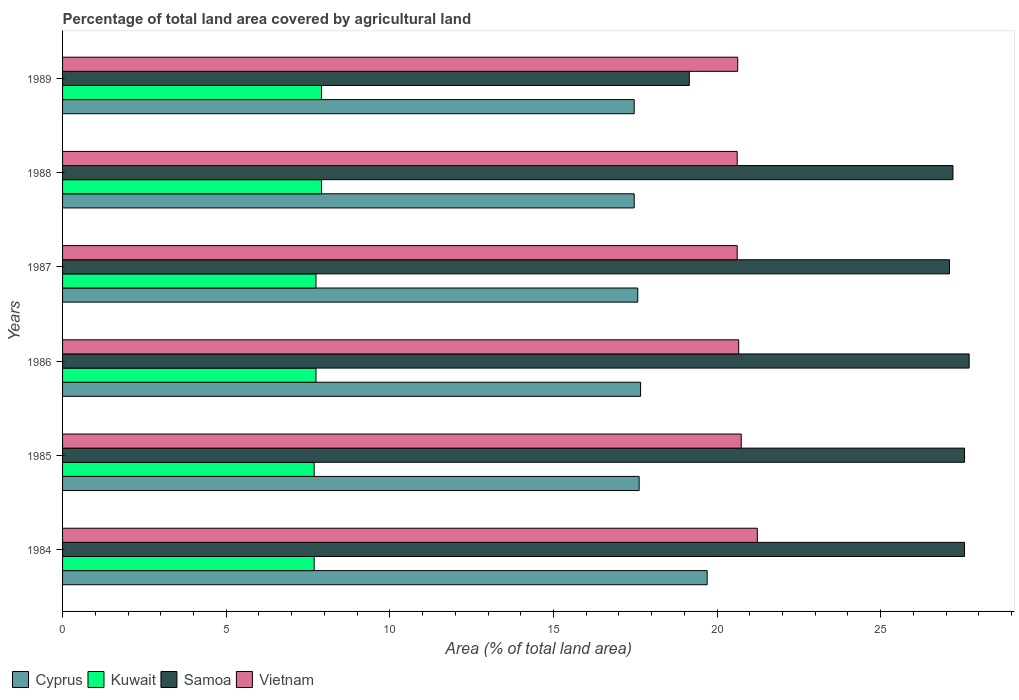How many groups of bars are there?
Offer a terse response. 6. How many bars are there on the 5th tick from the top?
Your answer should be very brief. 4. How many bars are there on the 4th tick from the bottom?
Your answer should be compact. 4. What is the percentage of agricultural land in Samoa in 1984?
Your answer should be very brief. 27.56. Across all years, what is the maximum percentage of agricultural land in Vietnam?
Your answer should be very brief. 21.23. Across all years, what is the minimum percentage of agricultural land in Samoa?
Keep it short and to the point. 19.15. In which year was the percentage of agricultural land in Vietnam minimum?
Ensure brevity in your answer.  1987. What is the total percentage of agricultural land in Cyprus in the graph?
Offer a very short reply. 107.49. What is the difference between the percentage of agricultural land in Kuwait in 1986 and that in 1987?
Offer a terse response. 0. What is the difference between the percentage of agricultural land in Cyprus in 1985 and the percentage of agricultural land in Kuwait in 1989?
Provide a short and direct response. 9.71. What is the average percentage of agricultural land in Cyprus per year?
Provide a succinct answer. 17.91. In the year 1984, what is the difference between the percentage of agricultural land in Kuwait and percentage of agricultural land in Vietnam?
Your response must be concise. -13.54. Is the difference between the percentage of agricultural land in Kuwait in 1985 and 1986 greater than the difference between the percentage of agricultural land in Vietnam in 1985 and 1986?
Your response must be concise. No. What is the difference between the highest and the second highest percentage of agricultural land in Kuwait?
Offer a terse response. 0. What is the difference between the highest and the lowest percentage of agricultural land in Samoa?
Keep it short and to the point. 8.55. What does the 3rd bar from the top in 1987 represents?
Your answer should be very brief. Kuwait. What does the 3rd bar from the bottom in 1989 represents?
Give a very brief answer. Samoa. Is it the case that in every year, the sum of the percentage of agricultural land in Vietnam and percentage of agricultural land in Cyprus is greater than the percentage of agricultural land in Samoa?
Make the answer very short. Yes. How many bars are there?
Give a very brief answer. 24. Are all the bars in the graph horizontal?
Make the answer very short. Yes. What is the difference between two consecutive major ticks on the X-axis?
Your response must be concise. 5. Does the graph contain any zero values?
Your answer should be compact. No. Does the graph contain grids?
Make the answer very short. No. What is the title of the graph?
Your answer should be very brief. Percentage of total land area covered by agricultural land. What is the label or title of the X-axis?
Your answer should be very brief. Area (% of total land area). What is the label or title of the Y-axis?
Keep it short and to the point. Years. What is the Area (% of total land area) of Cyprus in 1984?
Your answer should be compact. 19.7. What is the Area (% of total land area) in Kuwait in 1984?
Your response must be concise. 7.69. What is the Area (% of total land area) in Samoa in 1984?
Your answer should be very brief. 27.56. What is the Area (% of total land area) in Vietnam in 1984?
Make the answer very short. 21.23. What is the Area (% of total land area) in Cyprus in 1985?
Your answer should be very brief. 17.62. What is the Area (% of total land area) of Kuwait in 1985?
Provide a short and direct response. 7.69. What is the Area (% of total land area) of Samoa in 1985?
Keep it short and to the point. 27.56. What is the Area (% of total land area) of Vietnam in 1985?
Your answer should be compact. 20.74. What is the Area (% of total land area) in Cyprus in 1986?
Keep it short and to the point. 17.66. What is the Area (% of total land area) of Kuwait in 1986?
Your answer should be compact. 7.74. What is the Area (% of total land area) of Samoa in 1986?
Your answer should be compact. 27.7. What is the Area (% of total land area) in Vietnam in 1986?
Keep it short and to the point. 20.66. What is the Area (% of total land area) of Cyprus in 1987?
Offer a terse response. 17.58. What is the Area (% of total land area) in Kuwait in 1987?
Give a very brief answer. 7.74. What is the Area (% of total land area) of Samoa in 1987?
Give a very brief answer. 27.1. What is the Area (% of total land area) in Vietnam in 1987?
Provide a short and direct response. 20.62. What is the Area (% of total land area) of Cyprus in 1988?
Your response must be concise. 17.47. What is the Area (% of total land area) of Kuwait in 1988?
Your response must be concise. 7.91. What is the Area (% of total land area) in Samoa in 1988?
Your answer should be compact. 27.21. What is the Area (% of total land area) of Vietnam in 1988?
Offer a very short reply. 20.62. What is the Area (% of total land area) of Cyprus in 1989?
Keep it short and to the point. 17.47. What is the Area (% of total land area) of Kuwait in 1989?
Offer a terse response. 7.91. What is the Area (% of total land area) in Samoa in 1989?
Your response must be concise. 19.15. What is the Area (% of total land area) in Vietnam in 1989?
Your response must be concise. 20.63. Across all years, what is the maximum Area (% of total land area) in Cyprus?
Offer a terse response. 19.7. Across all years, what is the maximum Area (% of total land area) of Kuwait?
Give a very brief answer. 7.91. Across all years, what is the maximum Area (% of total land area) in Samoa?
Offer a terse response. 27.7. Across all years, what is the maximum Area (% of total land area) of Vietnam?
Your answer should be compact. 21.23. Across all years, what is the minimum Area (% of total land area) in Cyprus?
Provide a short and direct response. 17.47. Across all years, what is the minimum Area (% of total land area) in Kuwait?
Your response must be concise. 7.69. Across all years, what is the minimum Area (% of total land area) of Samoa?
Give a very brief answer. 19.15. Across all years, what is the minimum Area (% of total land area) in Vietnam?
Ensure brevity in your answer.  20.62. What is the total Area (% of total land area) in Cyprus in the graph?
Ensure brevity in your answer.  107.49. What is the total Area (% of total land area) of Kuwait in the graph?
Keep it short and to the point. 46.69. What is the total Area (% of total land area) of Samoa in the graph?
Give a very brief answer. 156.29. What is the total Area (% of total land area) in Vietnam in the graph?
Your answer should be compact. 124.49. What is the difference between the Area (% of total land area) of Cyprus in 1984 and that in 1985?
Give a very brief answer. 2.08. What is the difference between the Area (% of total land area) in Vietnam in 1984 and that in 1985?
Offer a very short reply. 0.49. What is the difference between the Area (% of total land area) in Cyprus in 1984 and that in 1986?
Provide a succinct answer. 2.03. What is the difference between the Area (% of total land area) in Kuwait in 1984 and that in 1986?
Ensure brevity in your answer.  -0.06. What is the difference between the Area (% of total land area) of Samoa in 1984 and that in 1986?
Give a very brief answer. -0.14. What is the difference between the Area (% of total land area) in Vietnam in 1984 and that in 1986?
Provide a succinct answer. 0.57. What is the difference between the Area (% of total land area) of Cyprus in 1984 and that in 1987?
Provide a succinct answer. 2.12. What is the difference between the Area (% of total land area) of Kuwait in 1984 and that in 1987?
Ensure brevity in your answer.  -0.06. What is the difference between the Area (% of total land area) of Samoa in 1984 and that in 1987?
Offer a very short reply. 0.46. What is the difference between the Area (% of total land area) in Vietnam in 1984 and that in 1987?
Provide a succinct answer. 0.61. What is the difference between the Area (% of total land area) in Cyprus in 1984 and that in 1988?
Make the answer very short. 2.23. What is the difference between the Area (% of total land area) in Kuwait in 1984 and that in 1988?
Keep it short and to the point. -0.22. What is the difference between the Area (% of total land area) of Samoa in 1984 and that in 1988?
Give a very brief answer. 0.35. What is the difference between the Area (% of total land area) in Vietnam in 1984 and that in 1988?
Your response must be concise. 0.61. What is the difference between the Area (% of total land area) of Cyprus in 1984 and that in 1989?
Provide a short and direct response. 2.23. What is the difference between the Area (% of total land area) in Kuwait in 1984 and that in 1989?
Make the answer very short. -0.22. What is the difference between the Area (% of total land area) in Samoa in 1984 and that in 1989?
Your answer should be very brief. 8.41. What is the difference between the Area (% of total land area) of Vietnam in 1984 and that in 1989?
Your response must be concise. 0.6. What is the difference between the Area (% of total land area) of Cyprus in 1985 and that in 1986?
Make the answer very short. -0.04. What is the difference between the Area (% of total land area) in Kuwait in 1985 and that in 1986?
Your answer should be very brief. -0.06. What is the difference between the Area (% of total land area) of Samoa in 1985 and that in 1986?
Your answer should be very brief. -0.14. What is the difference between the Area (% of total land area) in Vietnam in 1985 and that in 1986?
Provide a short and direct response. 0.08. What is the difference between the Area (% of total land area) of Cyprus in 1985 and that in 1987?
Your answer should be very brief. 0.04. What is the difference between the Area (% of total land area) in Kuwait in 1985 and that in 1987?
Ensure brevity in your answer.  -0.06. What is the difference between the Area (% of total land area) of Samoa in 1985 and that in 1987?
Make the answer very short. 0.46. What is the difference between the Area (% of total land area) in Vietnam in 1985 and that in 1987?
Offer a terse response. 0.12. What is the difference between the Area (% of total land area) of Cyprus in 1985 and that in 1988?
Offer a terse response. 0.15. What is the difference between the Area (% of total land area) in Kuwait in 1985 and that in 1988?
Make the answer very short. -0.22. What is the difference between the Area (% of total land area) of Samoa in 1985 and that in 1988?
Your answer should be compact. 0.35. What is the difference between the Area (% of total land area) in Vietnam in 1985 and that in 1988?
Provide a succinct answer. 0.12. What is the difference between the Area (% of total land area) in Cyprus in 1985 and that in 1989?
Provide a short and direct response. 0.15. What is the difference between the Area (% of total land area) in Kuwait in 1985 and that in 1989?
Offer a terse response. -0.22. What is the difference between the Area (% of total land area) in Samoa in 1985 and that in 1989?
Offer a very short reply. 8.41. What is the difference between the Area (% of total land area) of Vietnam in 1985 and that in 1989?
Make the answer very short. 0.11. What is the difference between the Area (% of total land area) in Cyprus in 1986 and that in 1987?
Make the answer very short. 0.09. What is the difference between the Area (% of total land area) of Samoa in 1986 and that in 1987?
Provide a short and direct response. 0.6. What is the difference between the Area (% of total land area) in Vietnam in 1986 and that in 1987?
Offer a terse response. 0.05. What is the difference between the Area (% of total land area) of Cyprus in 1986 and that in 1988?
Give a very brief answer. 0.19. What is the difference between the Area (% of total land area) in Kuwait in 1986 and that in 1988?
Offer a terse response. -0.17. What is the difference between the Area (% of total land area) of Samoa in 1986 and that in 1988?
Your response must be concise. 0.49. What is the difference between the Area (% of total land area) in Vietnam in 1986 and that in 1988?
Ensure brevity in your answer.  0.05. What is the difference between the Area (% of total land area) of Cyprus in 1986 and that in 1989?
Offer a terse response. 0.19. What is the difference between the Area (% of total land area) of Kuwait in 1986 and that in 1989?
Offer a very short reply. -0.17. What is the difference between the Area (% of total land area) in Samoa in 1986 and that in 1989?
Your answer should be very brief. 8.55. What is the difference between the Area (% of total land area) in Vietnam in 1986 and that in 1989?
Your response must be concise. 0.03. What is the difference between the Area (% of total land area) in Cyprus in 1987 and that in 1988?
Your answer should be compact. 0.11. What is the difference between the Area (% of total land area) in Kuwait in 1987 and that in 1988?
Provide a short and direct response. -0.17. What is the difference between the Area (% of total land area) in Samoa in 1987 and that in 1988?
Provide a succinct answer. -0.11. What is the difference between the Area (% of total land area) of Cyprus in 1987 and that in 1989?
Provide a succinct answer. 0.11. What is the difference between the Area (% of total land area) in Kuwait in 1987 and that in 1989?
Make the answer very short. -0.17. What is the difference between the Area (% of total land area) of Samoa in 1987 and that in 1989?
Give a very brief answer. 7.95. What is the difference between the Area (% of total land area) of Vietnam in 1987 and that in 1989?
Offer a very short reply. -0.02. What is the difference between the Area (% of total land area) in Samoa in 1988 and that in 1989?
Your answer should be compact. 8.06. What is the difference between the Area (% of total land area) in Vietnam in 1988 and that in 1989?
Your answer should be very brief. -0.02. What is the difference between the Area (% of total land area) of Cyprus in 1984 and the Area (% of total land area) of Kuwait in 1985?
Offer a terse response. 12.01. What is the difference between the Area (% of total land area) in Cyprus in 1984 and the Area (% of total land area) in Samoa in 1985?
Keep it short and to the point. -7.86. What is the difference between the Area (% of total land area) of Cyprus in 1984 and the Area (% of total land area) of Vietnam in 1985?
Give a very brief answer. -1.04. What is the difference between the Area (% of total land area) of Kuwait in 1984 and the Area (% of total land area) of Samoa in 1985?
Provide a succinct answer. -19.87. What is the difference between the Area (% of total land area) in Kuwait in 1984 and the Area (% of total land area) in Vietnam in 1985?
Give a very brief answer. -13.05. What is the difference between the Area (% of total land area) in Samoa in 1984 and the Area (% of total land area) in Vietnam in 1985?
Offer a very short reply. 6.82. What is the difference between the Area (% of total land area) of Cyprus in 1984 and the Area (% of total land area) of Kuwait in 1986?
Your answer should be compact. 11.95. What is the difference between the Area (% of total land area) in Cyprus in 1984 and the Area (% of total land area) in Samoa in 1986?
Your answer should be very brief. -8.01. What is the difference between the Area (% of total land area) in Cyprus in 1984 and the Area (% of total land area) in Vietnam in 1986?
Offer a terse response. -0.96. What is the difference between the Area (% of total land area) in Kuwait in 1984 and the Area (% of total land area) in Samoa in 1986?
Your response must be concise. -20.02. What is the difference between the Area (% of total land area) of Kuwait in 1984 and the Area (% of total land area) of Vietnam in 1986?
Ensure brevity in your answer.  -12.97. What is the difference between the Area (% of total land area) of Samoa in 1984 and the Area (% of total land area) of Vietnam in 1986?
Offer a terse response. 6.9. What is the difference between the Area (% of total land area) in Cyprus in 1984 and the Area (% of total land area) in Kuwait in 1987?
Make the answer very short. 11.95. What is the difference between the Area (% of total land area) of Cyprus in 1984 and the Area (% of total land area) of Samoa in 1987?
Your answer should be very brief. -7.41. What is the difference between the Area (% of total land area) in Cyprus in 1984 and the Area (% of total land area) in Vietnam in 1987?
Give a very brief answer. -0.92. What is the difference between the Area (% of total land area) of Kuwait in 1984 and the Area (% of total land area) of Samoa in 1987?
Offer a very short reply. -19.41. What is the difference between the Area (% of total land area) of Kuwait in 1984 and the Area (% of total land area) of Vietnam in 1987?
Your answer should be compact. -12.93. What is the difference between the Area (% of total land area) of Samoa in 1984 and the Area (% of total land area) of Vietnam in 1987?
Your answer should be very brief. 6.95. What is the difference between the Area (% of total land area) in Cyprus in 1984 and the Area (% of total land area) in Kuwait in 1988?
Give a very brief answer. 11.78. What is the difference between the Area (% of total land area) in Cyprus in 1984 and the Area (% of total land area) in Samoa in 1988?
Make the answer very short. -7.51. What is the difference between the Area (% of total land area) in Cyprus in 1984 and the Area (% of total land area) in Vietnam in 1988?
Keep it short and to the point. -0.92. What is the difference between the Area (% of total land area) of Kuwait in 1984 and the Area (% of total land area) of Samoa in 1988?
Make the answer very short. -19.52. What is the difference between the Area (% of total land area) in Kuwait in 1984 and the Area (% of total land area) in Vietnam in 1988?
Your response must be concise. -12.93. What is the difference between the Area (% of total land area) of Samoa in 1984 and the Area (% of total land area) of Vietnam in 1988?
Keep it short and to the point. 6.95. What is the difference between the Area (% of total land area) of Cyprus in 1984 and the Area (% of total land area) of Kuwait in 1989?
Keep it short and to the point. 11.78. What is the difference between the Area (% of total land area) in Cyprus in 1984 and the Area (% of total land area) in Samoa in 1989?
Offer a very short reply. 0.55. What is the difference between the Area (% of total land area) in Cyprus in 1984 and the Area (% of total land area) in Vietnam in 1989?
Offer a very short reply. -0.93. What is the difference between the Area (% of total land area) in Kuwait in 1984 and the Area (% of total land area) in Samoa in 1989?
Provide a short and direct response. -11.46. What is the difference between the Area (% of total land area) in Kuwait in 1984 and the Area (% of total land area) in Vietnam in 1989?
Give a very brief answer. -12.94. What is the difference between the Area (% of total land area) of Samoa in 1984 and the Area (% of total land area) of Vietnam in 1989?
Provide a succinct answer. 6.93. What is the difference between the Area (% of total land area) in Cyprus in 1985 and the Area (% of total land area) in Kuwait in 1986?
Provide a succinct answer. 9.87. What is the difference between the Area (% of total land area) in Cyprus in 1985 and the Area (% of total land area) in Samoa in 1986?
Provide a succinct answer. -10.08. What is the difference between the Area (% of total land area) of Cyprus in 1985 and the Area (% of total land area) of Vietnam in 1986?
Your answer should be compact. -3.04. What is the difference between the Area (% of total land area) of Kuwait in 1985 and the Area (% of total land area) of Samoa in 1986?
Give a very brief answer. -20.02. What is the difference between the Area (% of total land area) of Kuwait in 1985 and the Area (% of total land area) of Vietnam in 1986?
Offer a terse response. -12.97. What is the difference between the Area (% of total land area) in Samoa in 1985 and the Area (% of total land area) in Vietnam in 1986?
Your answer should be compact. 6.9. What is the difference between the Area (% of total land area) of Cyprus in 1985 and the Area (% of total land area) of Kuwait in 1987?
Your answer should be very brief. 9.87. What is the difference between the Area (% of total land area) in Cyprus in 1985 and the Area (% of total land area) in Samoa in 1987?
Make the answer very short. -9.48. What is the difference between the Area (% of total land area) of Cyprus in 1985 and the Area (% of total land area) of Vietnam in 1987?
Keep it short and to the point. -3. What is the difference between the Area (% of total land area) in Kuwait in 1985 and the Area (% of total land area) in Samoa in 1987?
Your response must be concise. -19.41. What is the difference between the Area (% of total land area) of Kuwait in 1985 and the Area (% of total land area) of Vietnam in 1987?
Ensure brevity in your answer.  -12.93. What is the difference between the Area (% of total land area) of Samoa in 1985 and the Area (% of total land area) of Vietnam in 1987?
Make the answer very short. 6.95. What is the difference between the Area (% of total land area) of Cyprus in 1985 and the Area (% of total land area) of Kuwait in 1988?
Offer a terse response. 9.71. What is the difference between the Area (% of total land area) of Cyprus in 1985 and the Area (% of total land area) of Samoa in 1988?
Offer a very short reply. -9.59. What is the difference between the Area (% of total land area) in Cyprus in 1985 and the Area (% of total land area) in Vietnam in 1988?
Provide a succinct answer. -3. What is the difference between the Area (% of total land area) of Kuwait in 1985 and the Area (% of total land area) of Samoa in 1988?
Your answer should be compact. -19.52. What is the difference between the Area (% of total land area) of Kuwait in 1985 and the Area (% of total land area) of Vietnam in 1988?
Offer a very short reply. -12.93. What is the difference between the Area (% of total land area) of Samoa in 1985 and the Area (% of total land area) of Vietnam in 1988?
Your answer should be compact. 6.95. What is the difference between the Area (% of total land area) in Cyprus in 1985 and the Area (% of total land area) in Kuwait in 1989?
Ensure brevity in your answer.  9.71. What is the difference between the Area (% of total land area) in Cyprus in 1985 and the Area (% of total land area) in Samoa in 1989?
Make the answer very short. -1.53. What is the difference between the Area (% of total land area) of Cyprus in 1985 and the Area (% of total land area) of Vietnam in 1989?
Make the answer very short. -3.01. What is the difference between the Area (% of total land area) of Kuwait in 1985 and the Area (% of total land area) of Samoa in 1989?
Provide a succinct answer. -11.46. What is the difference between the Area (% of total land area) of Kuwait in 1985 and the Area (% of total land area) of Vietnam in 1989?
Give a very brief answer. -12.94. What is the difference between the Area (% of total land area) in Samoa in 1985 and the Area (% of total land area) in Vietnam in 1989?
Provide a succinct answer. 6.93. What is the difference between the Area (% of total land area) of Cyprus in 1986 and the Area (% of total land area) of Kuwait in 1987?
Your answer should be compact. 9.92. What is the difference between the Area (% of total land area) of Cyprus in 1986 and the Area (% of total land area) of Samoa in 1987?
Offer a very short reply. -9.44. What is the difference between the Area (% of total land area) of Cyprus in 1986 and the Area (% of total land area) of Vietnam in 1987?
Your answer should be very brief. -2.95. What is the difference between the Area (% of total land area) in Kuwait in 1986 and the Area (% of total land area) in Samoa in 1987?
Make the answer very short. -19.36. What is the difference between the Area (% of total land area) of Kuwait in 1986 and the Area (% of total land area) of Vietnam in 1987?
Offer a very short reply. -12.87. What is the difference between the Area (% of total land area) of Samoa in 1986 and the Area (% of total land area) of Vietnam in 1987?
Your answer should be very brief. 7.09. What is the difference between the Area (% of total land area) of Cyprus in 1986 and the Area (% of total land area) of Kuwait in 1988?
Your response must be concise. 9.75. What is the difference between the Area (% of total land area) in Cyprus in 1986 and the Area (% of total land area) in Samoa in 1988?
Your response must be concise. -9.55. What is the difference between the Area (% of total land area) of Cyprus in 1986 and the Area (% of total land area) of Vietnam in 1988?
Give a very brief answer. -2.95. What is the difference between the Area (% of total land area) of Kuwait in 1986 and the Area (% of total land area) of Samoa in 1988?
Your answer should be compact. -19.46. What is the difference between the Area (% of total land area) of Kuwait in 1986 and the Area (% of total land area) of Vietnam in 1988?
Provide a succinct answer. -12.87. What is the difference between the Area (% of total land area) in Samoa in 1986 and the Area (% of total land area) in Vietnam in 1988?
Make the answer very short. 7.09. What is the difference between the Area (% of total land area) of Cyprus in 1986 and the Area (% of total land area) of Kuwait in 1989?
Provide a short and direct response. 9.75. What is the difference between the Area (% of total land area) in Cyprus in 1986 and the Area (% of total land area) in Samoa in 1989?
Provide a short and direct response. -1.49. What is the difference between the Area (% of total land area) in Cyprus in 1986 and the Area (% of total land area) in Vietnam in 1989?
Provide a succinct answer. -2.97. What is the difference between the Area (% of total land area) in Kuwait in 1986 and the Area (% of total land area) in Samoa in 1989?
Your response must be concise. -11.41. What is the difference between the Area (% of total land area) in Kuwait in 1986 and the Area (% of total land area) in Vietnam in 1989?
Ensure brevity in your answer.  -12.89. What is the difference between the Area (% of total land area) of Samoa in 1986 and the Area (% of total land area) of Vietnam in 1989?
Give a very brief answer. 7.07. What is the difference between the Area (% of total land area) of Cyprus in 1987 and the Area (% of total land area) of Kuwait in 1988?
Make the answer very short. 9.66. What is the difference between the Area (% of total land area) of Cyprus in 1987 and the Area (% of total land area) of Samoa in 1988?
Provide a succinct answer. -9.63. What is the difference between the Area (% of total land area) in Cyprus in 1987 and the Area (% of total land area) in Vietnam in 1988?
Provide a short and direct response. -3.04. What is the difference between the Area (% of total land area) in Kuwait in 1987 and the Area (% of total land area) in Samoa in 1988?
Keep it short and to the point. -19.46. What is the difference between the Area (% of total land area) in Kuwait in 1987 and the Area (% of total land area) in Vietnam in 1988?
Provide a short and direct response. -12.87. What is the difference between the Area (% of total land area) in Samoa in 1987 and the Area (% of total land area) in Vietnam in 1988?
Ensure brevity in your answer.  6.49. What is the difference between the Area (% of total land area) in Cyprus in 1987 and the Area (% of total land area) in Kuwait in 1989?
Your answer should be very brief. 9.66. What is the difference between the Area (% of total land area) in Cyprus in 1987 and the Area (% of total land area) in Samoa in 1989?
Make the answer very short. -1.58. What is the difference between the Area (% of total land area) of Cyprus in 1987 and the Area (% of total land area) of Vietnam in 1989?
Provide a short and direct response. -3.05. What is the difference between the Area (% of total land area) in Kuwait in 1987 and the Area (% of total land area) in Samoa in 1989?
Ensure brevity in your answer.  -11.41. What is the difference between the Area (% of total land area) in Kuwait in 1987 and the Area (% of total land area) in Vietnam in 1989?
Your answer should be compact. -12.89. What is the difference between the Area (% of total land area) of Samoa in 1987 and the Area (% of total land area) of Vietnam in 1989?
Give a very brief answer. 6.47. What is the difference between the Area (% of total land area) in Cyprus in 1988 and the Area (% of total land area) in Kuwait in 1989?
Offer a very short reply. 9.56. What is the difference between the Area (% of total land area) of Cyprus in 1988 and the Area (% of total land area) of Samoa in 1989?
Give a very brief answer. -1.68. What is the difference between the Area (% of total land area) of Cyprus in 1988 and the Area (% of total land area) of Vietnam in 1989?
Your answer should be very brief. -3.16. What is the difference between the Area (% of total land area) of Kuwait in 1988 and the Area (% of total land area) of Samoa in 1989?
Offer a terse response. -11.24. What is the difference between the Area (% of total land area) in Kuwait in 1988 and the Area (% of total land area) in Vietnam in 1989?
Your response must be concise. -12.72. What is the difference between the Area (% of total land area) of Samoa in 1988 and the Area (% of total land area) of Vietnam in 1989?
Make the answer very short. 6.58. What is the average Area (% of total land area) in Cyprus per year?
Your answer should be very brief. 17.91. What is the average Area (% of total land area) of Kuwait per year?
Ensure brevity in your answer.  7.78. What is the average Area (% of total land area) of Samoa per year?
Keep it short and to the point. 26.05. What is the average Area (% of total land area) in Vietnam per year?
Offer a very short reply. 20.75. In the year 1984, what is the difference between the Area (% of total land area) in Cyprus and Area (% of total land area) in Kuwait?
Offer a terse response. 12.01. In the year 1984, what is the difference between the Area (% of total land area) of Cyprus and Area (% of total land area) of Samoa?
Ensure brevity in your answer.  -7.86. In the year 1984, what is the difference between the Area (% of total land area) in Cyprus and Area (% of total land area) in Vietnam?
Ensure brevity in your answer.  -1.53. In the year 1984, what is the difference between the Area (% of total land area) of Kuwait and Area (% of total land area) of Samoa?
Ensure brevity in your answer.  -19.87. In the year 1984, what is the difference between the Area (% of total land area) in Kuwait and Area (% of total land area) in Vietnam?
Provide a succinct answer. -13.54. In the year 1984, what is the difference between the Area (% of total land area) of Samoa and Area (% of total land area) of Vietnam?
Provide a short and direct response. 6.33. In the year 1985, what is the difference between the Area (% of total land area) of Cyprus and Area (% of total land area) of Kuwait?
Ensure brevity in your answer.  9.93. In the year 1985, what is the difference between the Area (% of total land area) in Cyprus and Area (% of total land area) in Samoa?
Your response must be concise. -9.94. In the year 1985, what is the difference between the Area (% of total land area) in Cyprus and Area (% of total land area) in Vietnam?
Keep it short and to the point. -3.12. In the year 1985, what is the difference between the Area (% of total land area) in Kuwait and Area (% of total land area) in Samoa?
Your response must be concise. -19.87. In the year 1985, what is the difference between the Area (% of total land area) of Kuwait and Area (% of total land area) of Vietnam?
Your answer should be compact. -13.05. In the year 1985, what is the difference between the Area (% of total land area) of Samoa and Area (% of total land area) of Vietnam?
Ensure brevity in your answer.  6.82. In the year 1986, what is the difference between the Area (% of total land area) in Cyprus and Area (% of total land area) in Kuwait?
Your response must be concise. 9.92. In the year 1986, what is the difference between the Area (% of total land area) in Cyprus and Area (% of total land area) in Samoa?
Offer a terse response. -10.04. In the year 1986, what is the difference between the Area (% of total land area) of Cyprus and Area (% of total land area) of Vietnam?
Provide a short and direct response. -3. In the year 1986, what is the difference between the Area (% of total land area) of Kuwait and Area (% of total land area) of Samoa?
Your answer should be very brief. -19.96. In the year 1986, what is the difference between the Area (% of total land area) of Kuwait and Area (% of total land area) of Vietnam?
Offer a very short reply. -12.92. In the year 1986, what is the difference between the Area (% of total land area) in Samoa and Area (% of total land area) in Vietnam?
Make the answer very short. 7.04. In the year 1987, what is the difference between the Area (% of total land area) of Cyprus and Area (% of total land area) of Kuwait?
Offer a terse response. 9.83. In the year 1987, what is the difference between the Area (% of total land area) in Cyprus and Area (% of total land area) in Samoa?
Provide a short and direct response. -9.53. In the year 1987, what is the difference between the Area (% of total land area) in Cyprus and Area (% of total land area) in Vietnam?
Offer a very short reply. -3.04. In the year 1987, what is the difference between the Area (% of total land area) in Kuwait and Area (% of total land area) in Samoa?
Your answer should be compact. -19.36. In the year 1987, what is the difference between the Area (% of total land area) in Kuwait and Area (% of total land area) in Vietnam?
Offer a very short reply. -12.87. In the year 1987, what is the difference between the Area (% of total land area) in Samoa and Area (% of total land area) in Vietnam?
Keep it short and to the point. 6.49. In the year 1988, what is the difference between the Area (% of total land area) in Cyprus and Area (% of total land area) in Kuwait?
Give a very brief answer. 9.56. In the year 1988, what is the difference between the Area (% of total land area) in Cyprus and Area (% of total land area) in Samoa?
Make the answer very short. -9.74. In the year 1988, what is the difference between the Area (% of total land area) in Cyprus and Area (% of total land area) in Vietnam?
Give a very brief answer. -3.15. In the year 1988, what is the difference between the Area (% of total land area) of Kuwait and Area (% of total land area) of Samoa?
Give a very brief answer. -19.3. In the year 1988, what is the difference between the Area (% of total land area) in Kuwait and Area (% of total land area) in Vietnam?
Your answer should be very brief. -12.7. In the year 1988, what is the difference between the Area (% of total land area) in Samoa and Area (% of total land area) in Vietnam?
Provide a succinct answer. 6.59. In the year 1989, what is the difference between the Area (% of total land area) of Cyprus and Area (% of total land area) of Kuwait?
Make the answer very short. 9.56. In the year 1989, what is the difference between the Area (% of total land area) in Cyprus and Area (% of total land area) in Samoa?
Your response must be concise. -1.68. In the year 1989, what is the difference between the Area (% of total land area) in Cyprus and Area (% of total land area) in Vietnam?
Make the answer very short. -3.16. In the year 1989, what is the difference between the Area (% of total land area) of Kuwait and Area (% of total land area) of Samoa?
Offer a terse response. -11.24. In the year 1989, what is the difference between the Area (% of total land area) of Kuwait and Area (% of total land area) of Vietnam?
Offer a very short reply. -12.72. In the year 1989, what is the difference between the Area (% of total land area) in Samoa and Area (% of total land area) in Vietnam?
Your answer should be compact. -1.48. What is the ratio of the Area (% of total land area) in Cyprus in 1984 to that in 1985?
Keep it short and to the point. 1.12. What is the ratio of the Area (% of total land area) in Vietnam in 1984 to that in 1985?
Your answer should be compact. 1.02. What is the ratio of the Area (% of total land area) of Cyprus in 1984 to that in 1986?
Give a very brief answer. 1.12. What is the ratio of the Area (% of total land area) of Kuwait in 1984 to that in 1986?
Your answer should be compact. 0.99. What is the ratio of the Area (% of total land area) in Samoa in 1984 to that in 1986?
Offer a terse response. 0.99. What is the ratio of the Area (% of total land area) in Vietnam in 1984 to that in 1986?
Give a very brief answer. 1.03. What is the ratio of the Area (% of total land area) in Cyprus in 1984 to that in 1987?
Give a very brief answer. 1.12. What is the ratio of the Area (% of total land area) of Samoa in 1984 to that in 1987?
Ensure brevity in your answer.  1.02. What is the ratio of the Area (% of total land area) of Vietnam in 1984 to that in 1987?
Ensure brevity in your answer.  1.03. What is the ratio of the Area (% of total land area) of Cyprus in 1984 to that in 1988?
Your answer should be very brief. 1.13. What is the ratio of the Area (% of total land area) of Kuwait in 1984 to that in 1988?
Provide a succinct answer. 0.97. What is the ratio of the Area (% of total land area) of Samoa in 1984 to that in 1988?
Ensure brevity in your answer.  1.01. What is the ratio of the Area (% of total land area) of Vietnam in 1984 to that in 1988?
Provide a short and direct response. 1.03. What is the ratio of the Area (% of total land area) in Cyprus in 1984 to that in 1989?
Keep it short and to the point. 1.13. What is the ratio of the Area (% of total land area) in Kuwait in 1984 to that in 1989?
Provide a short and direct response. 0.97. What is the ratio of the Area (% of total land area) in Samoa in 1984 to that in 1989?
Provide a short and direct response. 1.44. What is the ratio of the Area (% of total land area) of Cyprus in 1985 to that in 1986?
Keep it short and to the point. 1. What is the ratio of the Area (% of total land area) in Samoa in 1985 to that in 1987?
Your answer should be very brief. 1.02. What is the ratio of the Area (% of total land area) in Vietnam in 1985 to that in 1987?
Offer a very short reply. 1.01. What is the ratio of the Area (% of total land area) of Cyprus in 1985 to that in 1988?
Your answer should be very brief. 1.01. What is the ratio of the Area (% of total land area) of Kuwait in 1985 to that in 1988?
Your answer should be compact. 0.97. What is the ratio of the Area (% of total land area) in Vietnam in 1985 to that in 1988?
Keep it short and to the point. 1.01. What is the ratio of the Area (% of total land area) of Cyprus in 1985 to that in 1989?
Ensure brevity in your answer.  1.01. What is the ratio of the Area (% of total land area) in Kuwait in 1985 to that in 1989?
Your answer should be compact. 0.97. What is the ratio of the Area (% of total land area) of Samoa in 1985 to that in 1989?
Offer a terse response. 1.44. What is the ratio of the Area (% of total land area) in Samoa in 1986 to that in 1987?
Your answer should be very brief. 1.02. What is the ratio of the Area (% of total land area) in Vietnam in 1986 to that in 1987?
Make the answer very short. 1. What is the ratio of the Area (% of total land area) of Cyprus in 1986 to that in 1988?
Keep it short and to the point. 1.01. What is the ratio of the Area (% of total land area) in Kuwait in 1986 to that in 1988?
Offer a very short reply. 0.98. What is the ratio of the Area (% of total land area) in Samoa in 1986 to that in 1988?
Ensure brevity in your answer.  1.02. What is the ratio of the Area (% of total land area) of Vietnam in 1986 to that in 1988?
Provide a succinct answer. 1. What is the ratio of the Area (% of total land area) of Cyprus in 1986 to that in 1989?
Offer a terse response. 1.01. What is the ratio of the Area (% of total land area) in Kuwait in 1986 to that in 1989?
Your response must be concise. 0.98. What is the ratio of the Area (% of total land area) in Samoa in 1986 to that in 1989?
Keep it short and to the point. 1.45. What is the ratio of the Area (% of total land area) in Kuwait in 1987 to that in 1988?
Provide a succinct answer. 0.98. What is the ratio of the Area (% of total land area) of Samoa in 1987 to that in 1988?
Your answer should be compact. 1. What is the ratio of the Area (% of total land area) in Vietnam in 1987 to that in 1988?
Ensure brevity in your answer.  1. What is the ratio of the Area (% of total land area) of Cyprus in 1987 to that in 1989?
Offer a terse response. 1.01. What is the ratio of the Area (% of total land area) in Kuwait in 1987 to that in 1989?
Provide a short and direct response. 0.98. What is the ratio of the Area (% of total land area) of Samoa in 1987 to that in 1989?
Keep it short and to the point. 1.42. What is the ratio of the Area (% of total land area) in Kuwait in 1988 to that in 1989?
Make the answer very short. 1. What is the ratio of the Area (% of total land area) of Samoa in 1988 to that in 1989?
Your answer should be very brief. 1.42. What is the ratio of the Area (% of total land area) in Vietnam in 1988 to that in 1989?
Offer a very short reply. 1. What is the difference between the highest and the second highest Area (% of total land area) of Cyprus?
Your response must be concise. 2.03. What is the difference between the highest and the second highest Area (% of total land area) in Samoa?
Keep it short and to the point. 0.14. What is the difference between the highest and the second highest Area (% of total land area) of Vietnam?
Provide a short and direct response. 0.49. What is the difference between the highest and the lowest Area (% of total land area) of Cyprus?
Your answer should be very brief. 2.23. What is the difference between the highest and the lowest Area (% of total land area) of Kuwait?
Offer a terse response. 0.22. What is the difference between the highest and the lowest Area (% of total land area) in Samoa?
Your response must be concise. 8.55. What is the difference between the highest and the lowest Area (% of total land area) of Vietnam?
Keep it short and to the point. 0.61. 